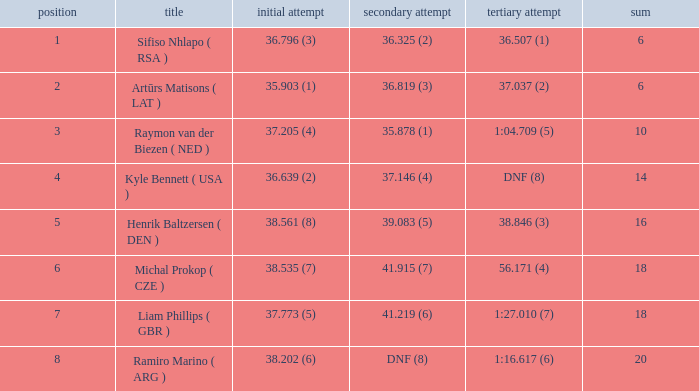Which average rank has a total of 16? 5.0. 